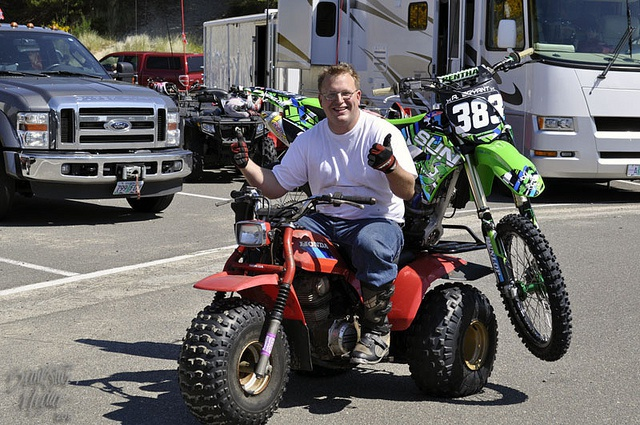Describe the objects in this image and their specific colors. I can see motorcycle in black, gray, maroon, and darkgray tones, truck in black and gray tones, bus in black and gray tones, motorcycle in black, gray, darkgray, and lightgray tones, and truck in black, darkgray, and gray tones in this image. 